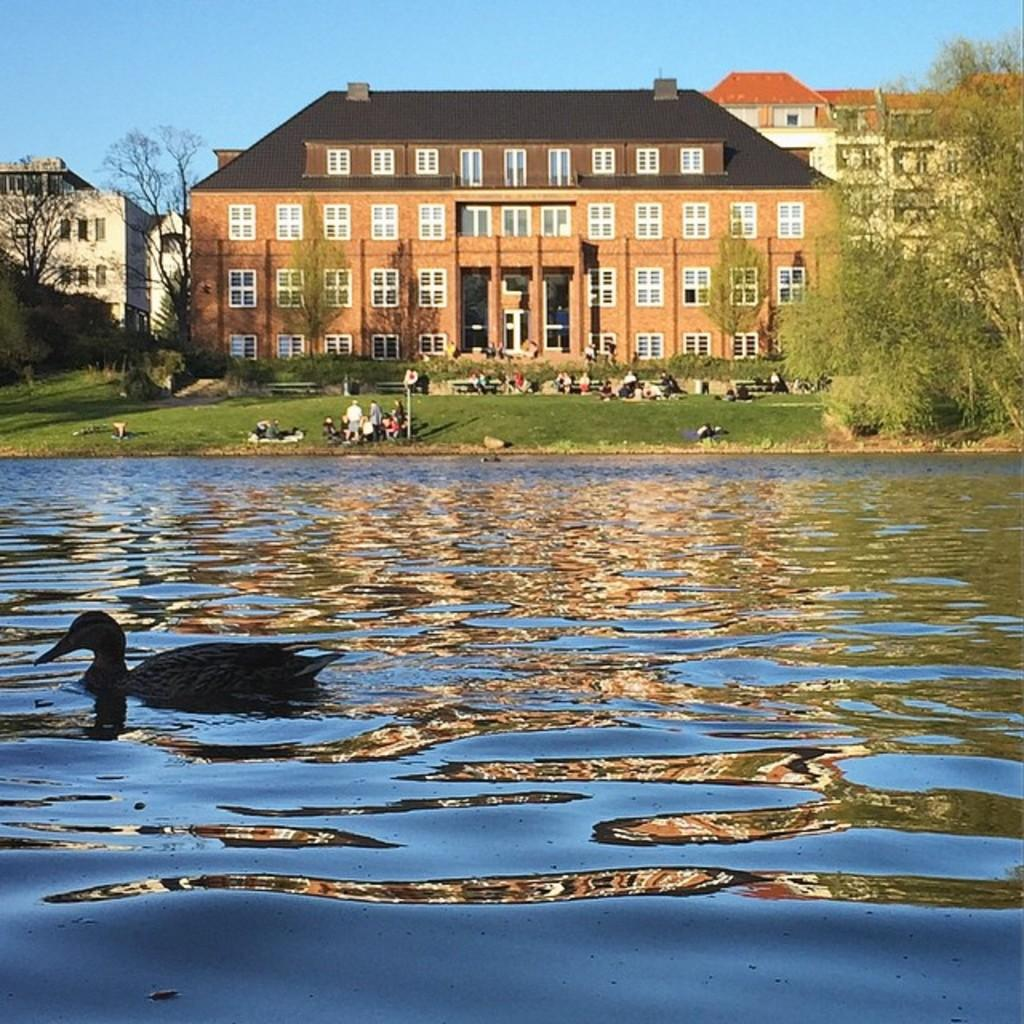What is visible in the image? Water is visible in the image. What can be seen in the background of the image? There are buildings, trees, and people in the background of the image. What direction is the doctor facing in the image? There is no doctor present in the image. What type of credit can be seen in the image? There is no credit visible in the image. 